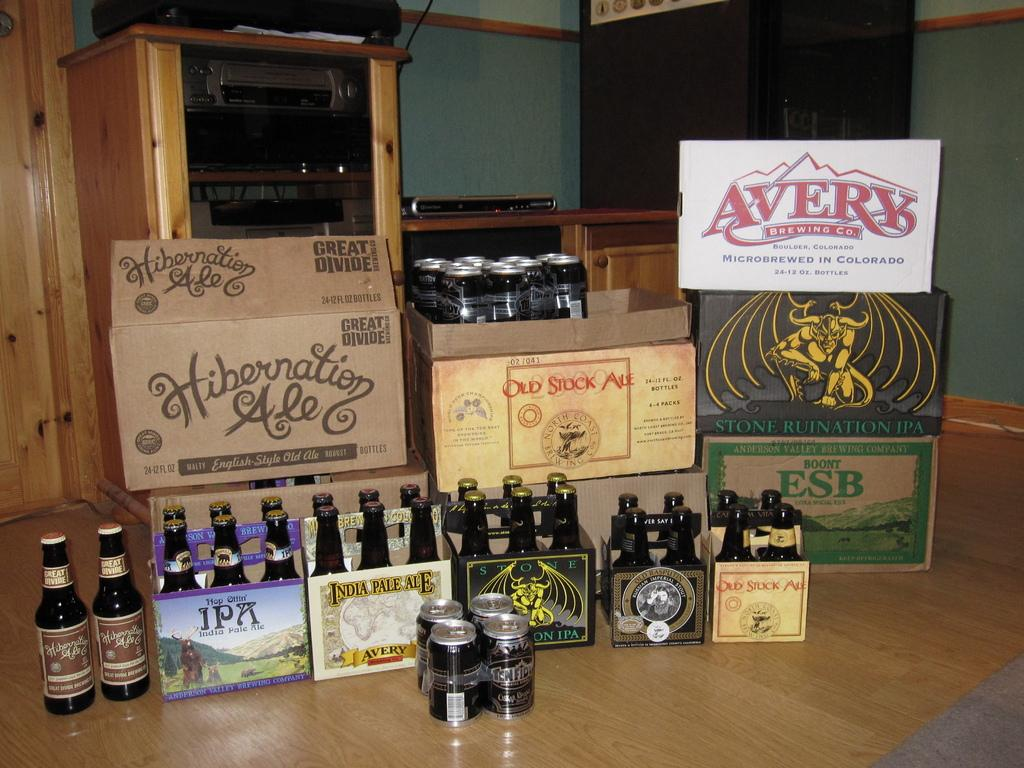<image>
Share a concise interpretation of the image provided. A collection of beer including one called Avery and one called Old Stock Ale. 